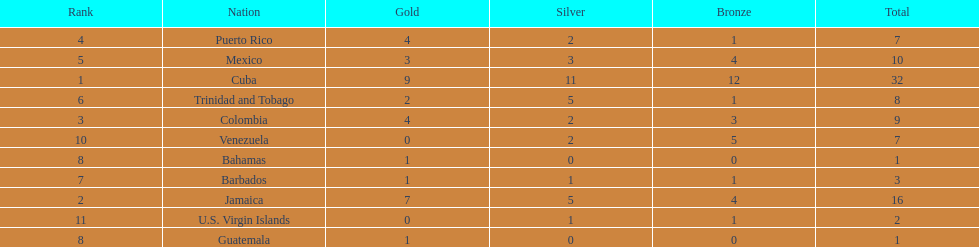What is the total number of gold medals awarded between these 11 countries? 32. 